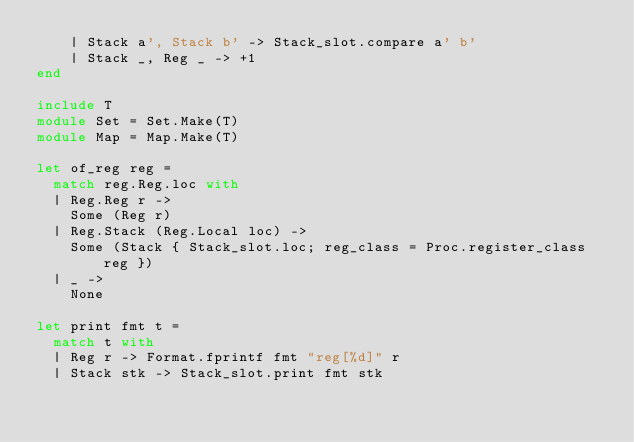Convert code to text. <code><loc_0><loc_0><loc_500><loc_500><_OCaml_>    | Stack a', Stack b' -> Stack_slot.compare a' b'
    | Stack _, Reg _ -> +1
end

include T
module Set = Set.Make(T)
module Map = Map.Make(T)

let of_reg reg =
  match reg.Reg.loc with
  | Reg.Reg r ->
    Some (Reg r)
  | Reg.Stack (Reg.Local loc) ->
    Some (Stack { Stack_slot.loc; reg_class = Proc.register_class reg })
  | _ ->
    None

let print fmt t =
  match t with
  | Reg r -> Format.fprintf fmt "reg[%d]" r
  | Stack stk -> Stack_slot.print fmt stk
</code> 